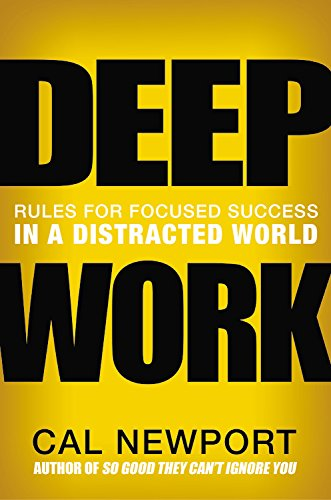Can you explain how the concept of 'Deep Work' is applied in everyday professional activities? Deep Work' refers to focused, undistracted work that pushes your cognitive capabilities to their limit. These efforts create new value, improve your skill, and are hard to replicate. In professional activities, it involves scheduling uninterrupted hours where emails, social media, and all other distractions are avoided to focus intensely on demanding tasks. 